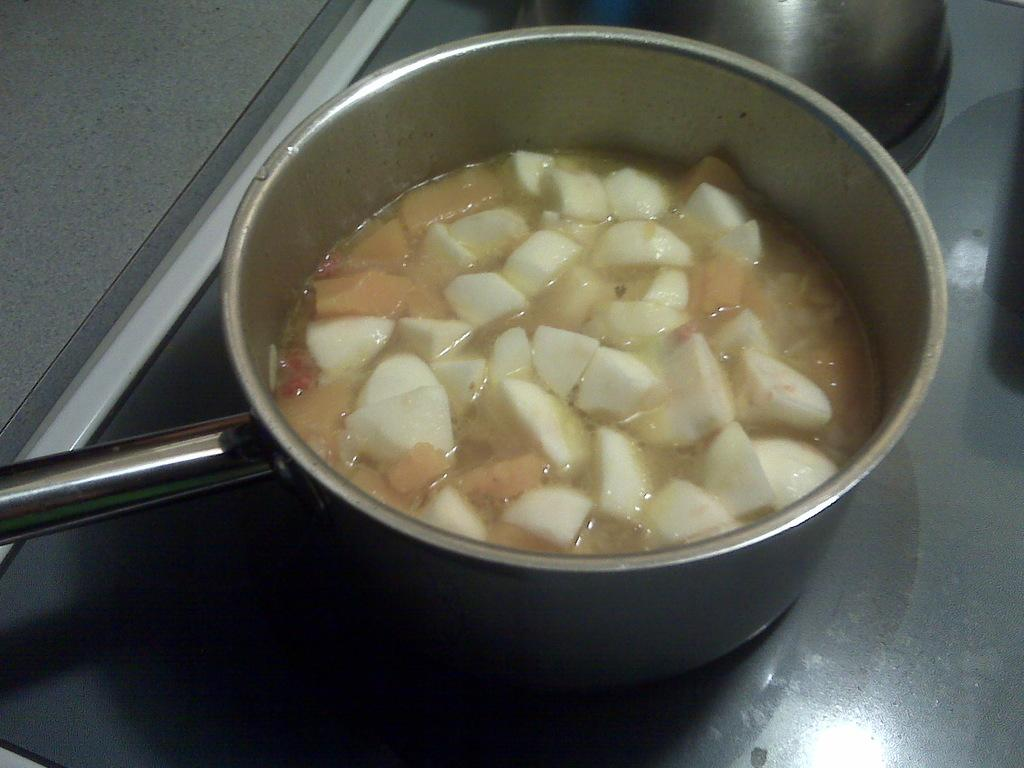How many vessels can be seen in the image? There are two vessels in the image. Where are the vessels placed? The vessels are kept on a surface. What is inside the first vessel? There is a food item in the first vessel. How many kittens are playing with the machine in the image? There are no kittens or machines present in the image. 